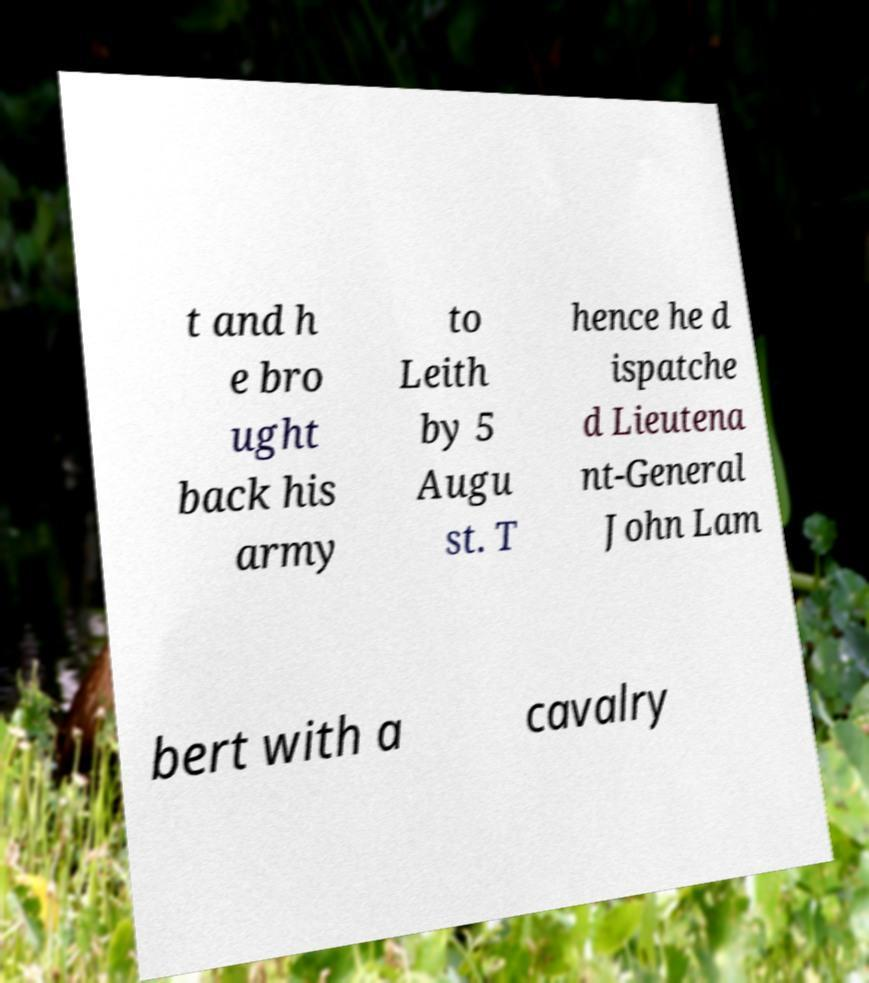I need the written content from this picture converted into text. Can you do that? t and h e bro ught back his army to Leith by 5 Augu st. T hence he d ispatche d Lieutena nt-General John Lam bert with a cavalry 